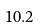<formula> <loc_0><loc_0><loc_500><loc_500>1 0 . 2</formula> 